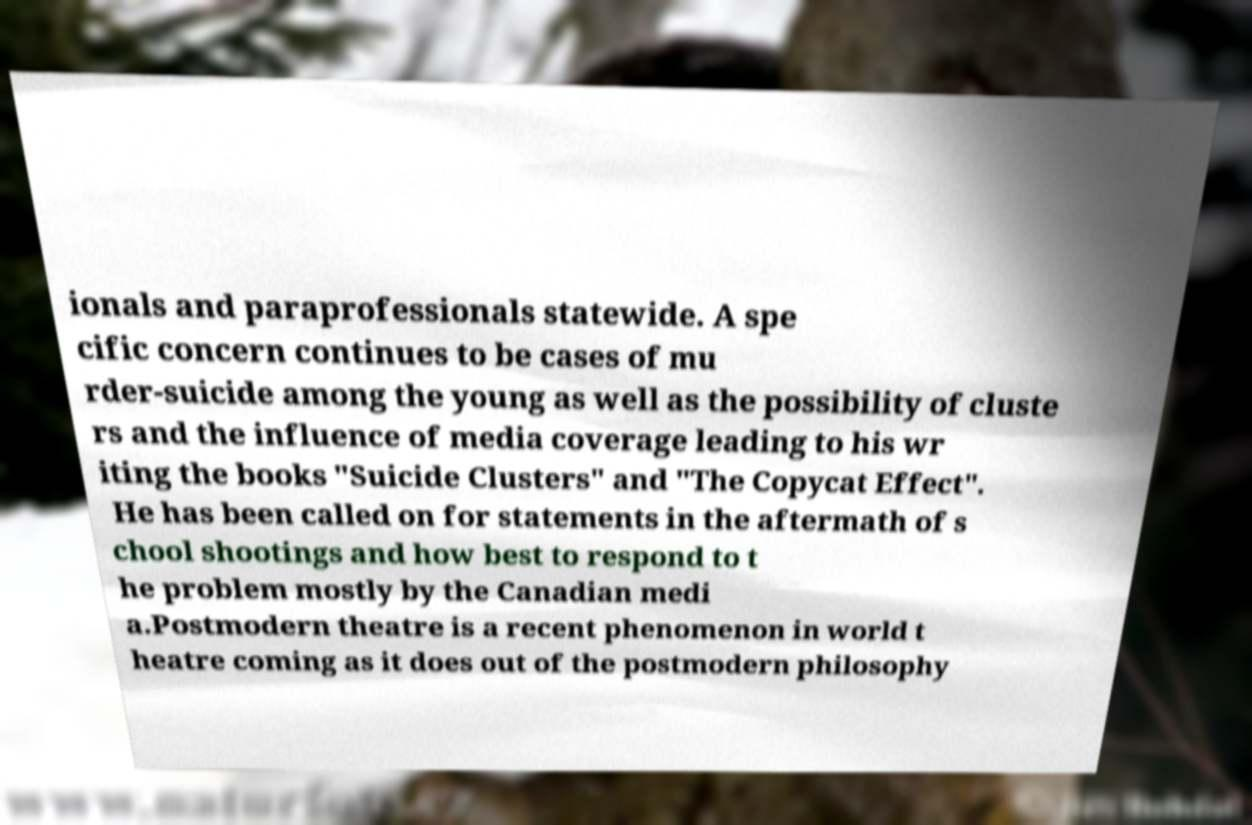Can you read and provide the text displayed in the image?This photo seems to have some interesting text. Can you extract and type it out for me? ionals and paraprofessionals statewide. A spe cific concern continues to be cases of mu rder-suicide among the young as well as the possibility of cluste rs and the influence of media coverage leading to his wr iting the books "Suicide Clusters" and "The Copycat Effect". He has been called on for statements in the aftermath of s chool shootings and how best to respond to t he problem mostly by the Canadian medi a.Postmodern theatre is a recent phenomenon in world t heatre coming as it does out of the postmodern philosophy 